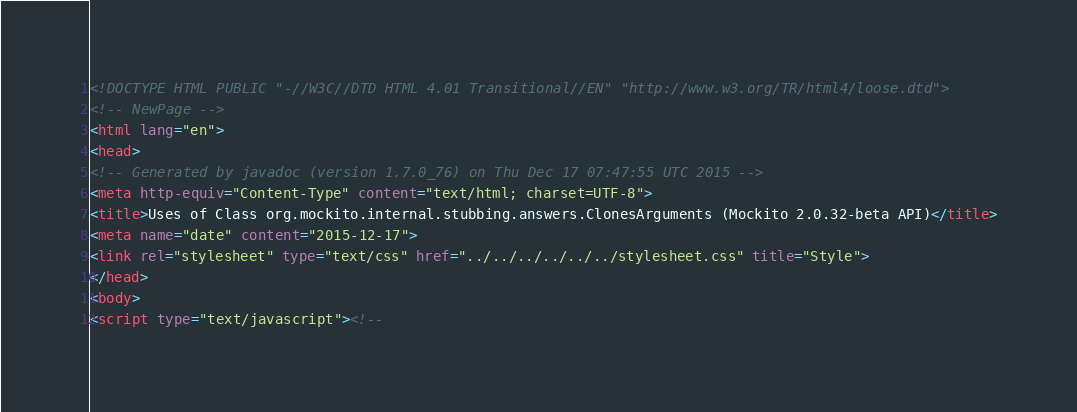<code> <loc_0><loc_0><loc_500><loc_500><_HTML_><!DOCTYPE HTML PUBLIC "-//W3C//DTD HTML 4.01 Transitional//EN" "http://www.w3.org/TR/html4/loose.dtd">
<!-- NewPage -->
<html lang="en">
<head>
<!-- Generated by javadoc (version 1.7.0_76) on Thu Dec 17 07:47:55 UTC 2015 -->
<meta http-equiv="Content-Type" content="text/html; charset=UTF-8">
<title>Uses of Class org.mockito.internal.stubbing.answers.ClonesArguments (Mockito 2.0.32-beta API)</title>
<meta name="date" content="2015-12-17">
<link rel="stylesheet" type="text/css" href="../../../../../../stylesheet.css" title="Style">
</head>
<body>
<script type="text/javascript"><!--</code> 